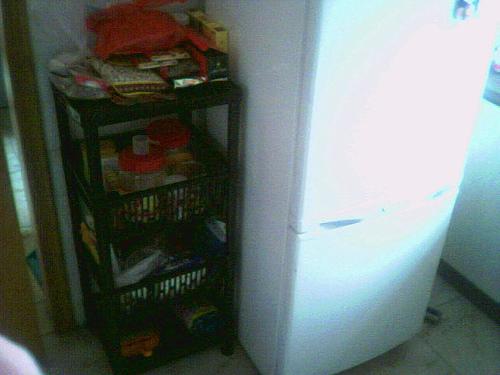Is this purse red?
Keep it brief. Yes. Does this person like peanut butter?
Be succinct. Yes. What color are the bins?
Short answer required. Black. What major appliance is shown?
Quick response, please. Refrigerator. 